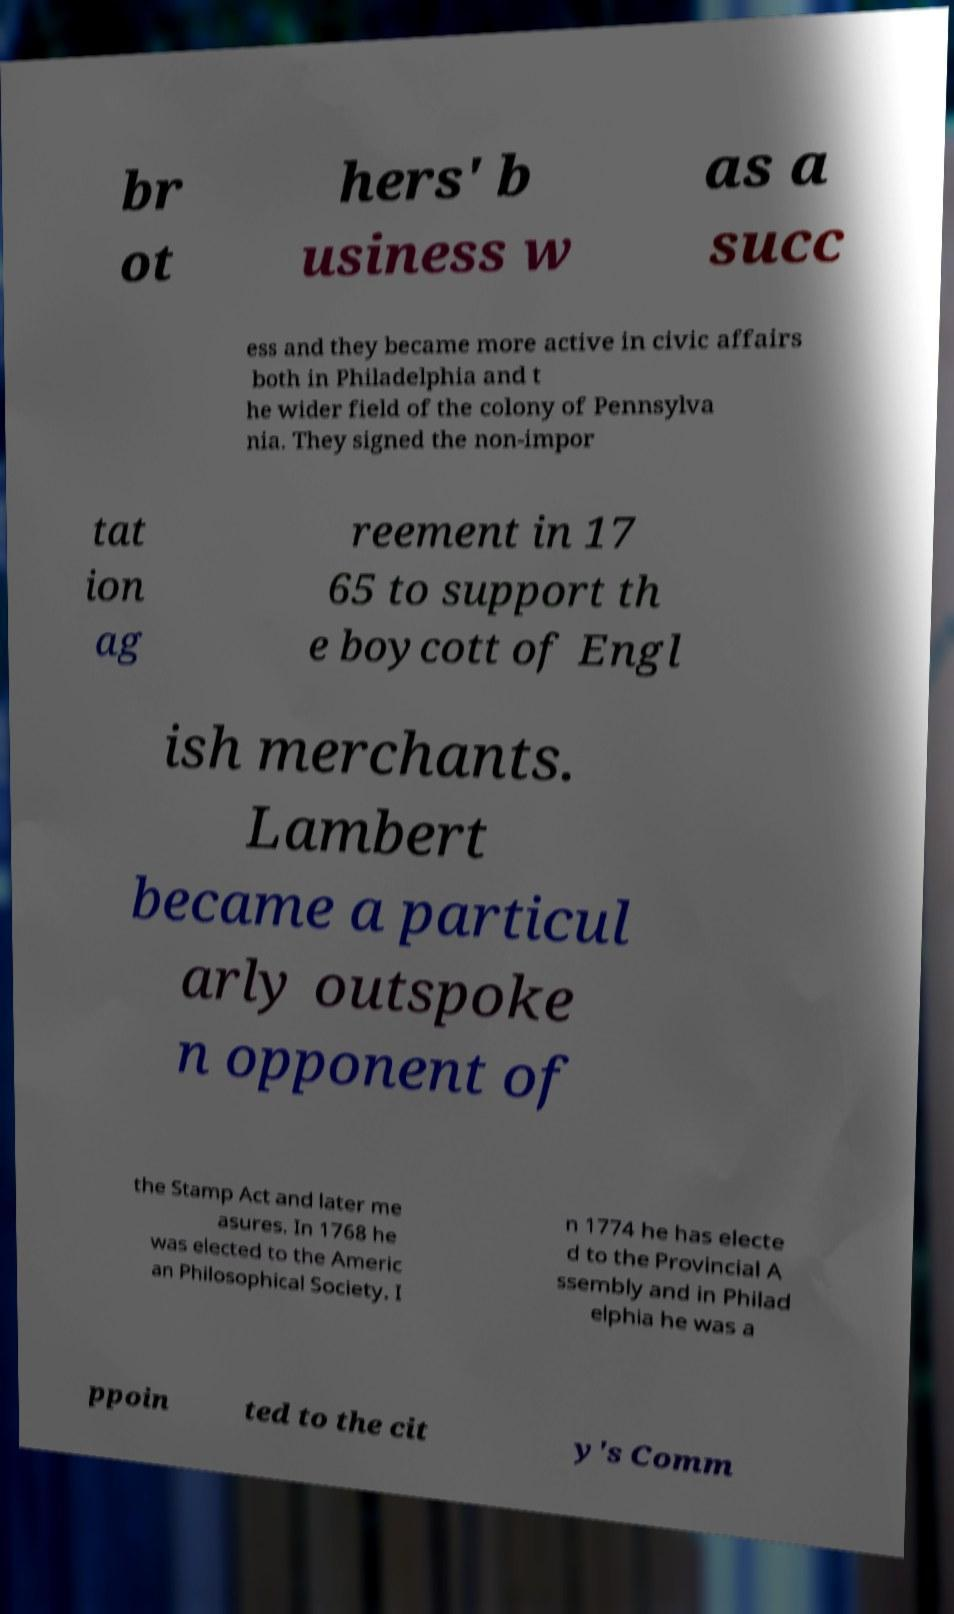Please read and relay the text visible in this image. What does it say? br ot hers' b usiness w as a succ ess and they became more active in civic affairs both in Philadelphia and t he wider field of the colony of Pennsylva nia. They signed the non-impor tat ion ag reement in 17 65 to support th e boycott of Engl ish merchants. Lambert became a particul arly outspoke n opponent of the Stamp Act and later me asures. In 1768 he was elected to the Americ an Philosophical Society. I n 1774 he has electe d to the Provincial A ssembly and in Philad elphia he was a ppoin ted to the cit y's Comm 